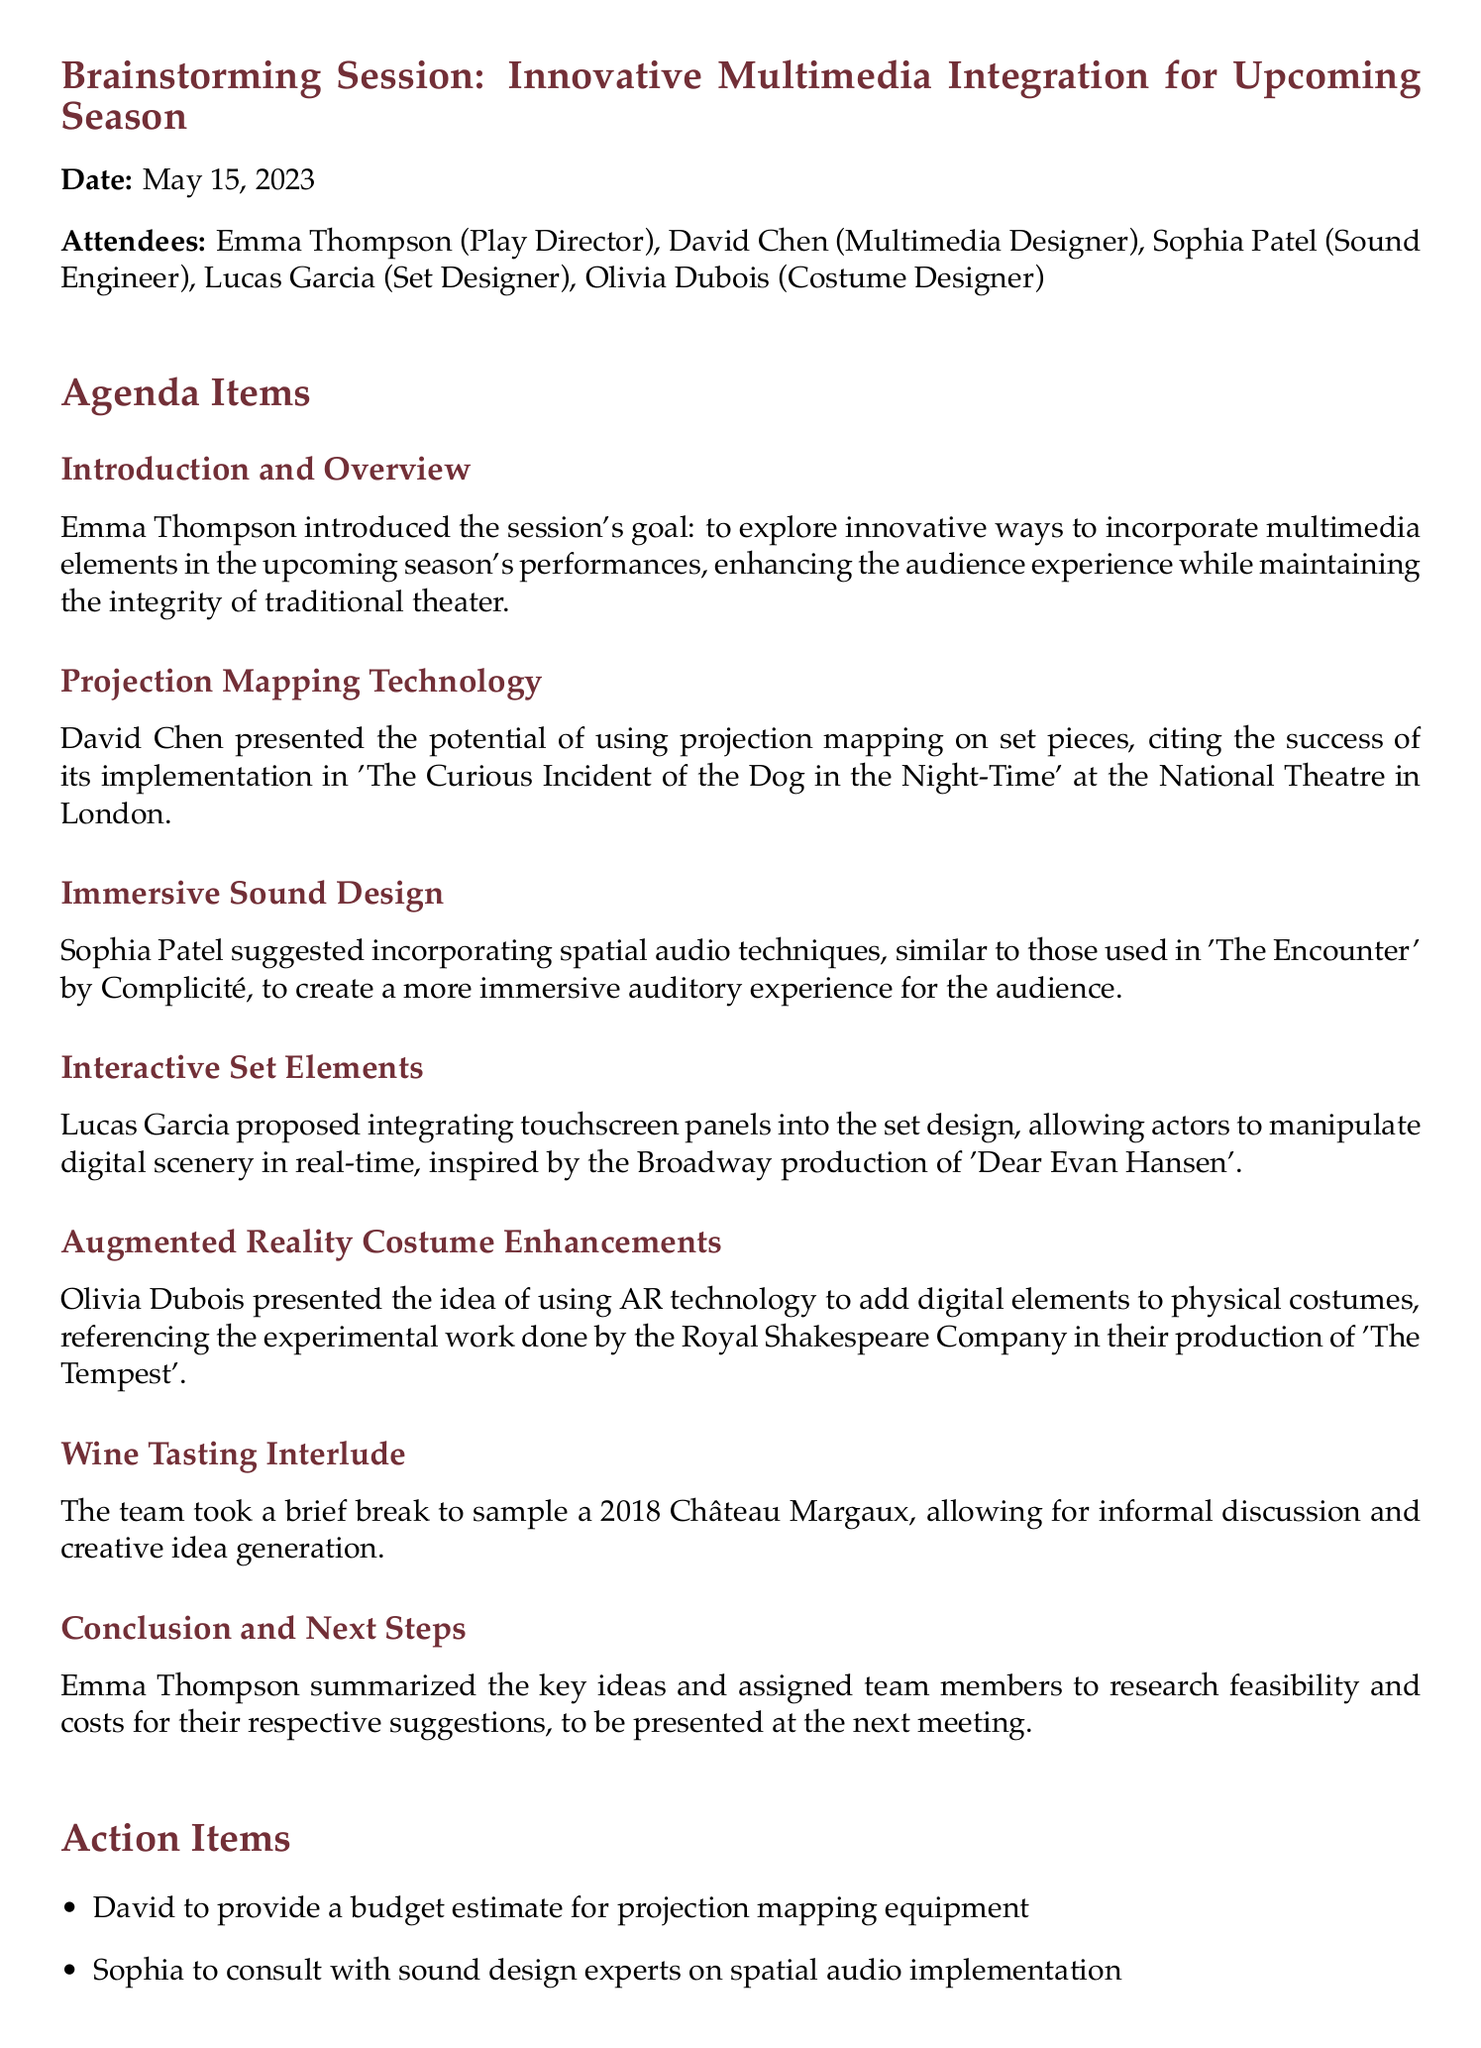What is the date of the meeting? The date is explicitly mentioned in the document under the title section.
Answer: May 15, 2023 Who presented the idea of using projection mapping technology? This information is found in the agenda item related to projection mapping technology.
Answer: David Chen What multimedia technique did Sophia Patel suggest? This inquiry pertains to the immersive sound design section of the document.
Answer: Spatial audio techniques Which wine was sampled during the break? The document specifies the wine during the wine tasting interlude.
Answer: 2018 Château Margaux What action item was assigned to Lucas? This question relates to the action items at the end of the document.
Answer: Create mock-ups of interactive set designs What was the main goal of the brainstorming session? The overall goal is outlined in the introduction and overview section.
Answer: Innovative ways to incorporate multimedia elements Who is responsible for scheduling the follow-up meeting? This information is derived from the conclusion and next steps section.
Answer: Emma What production inspired the idea of touchscreen panels? The document mentions a Broadway production in context with the interactive set elements.
Answer: Dear Evan Hansen 